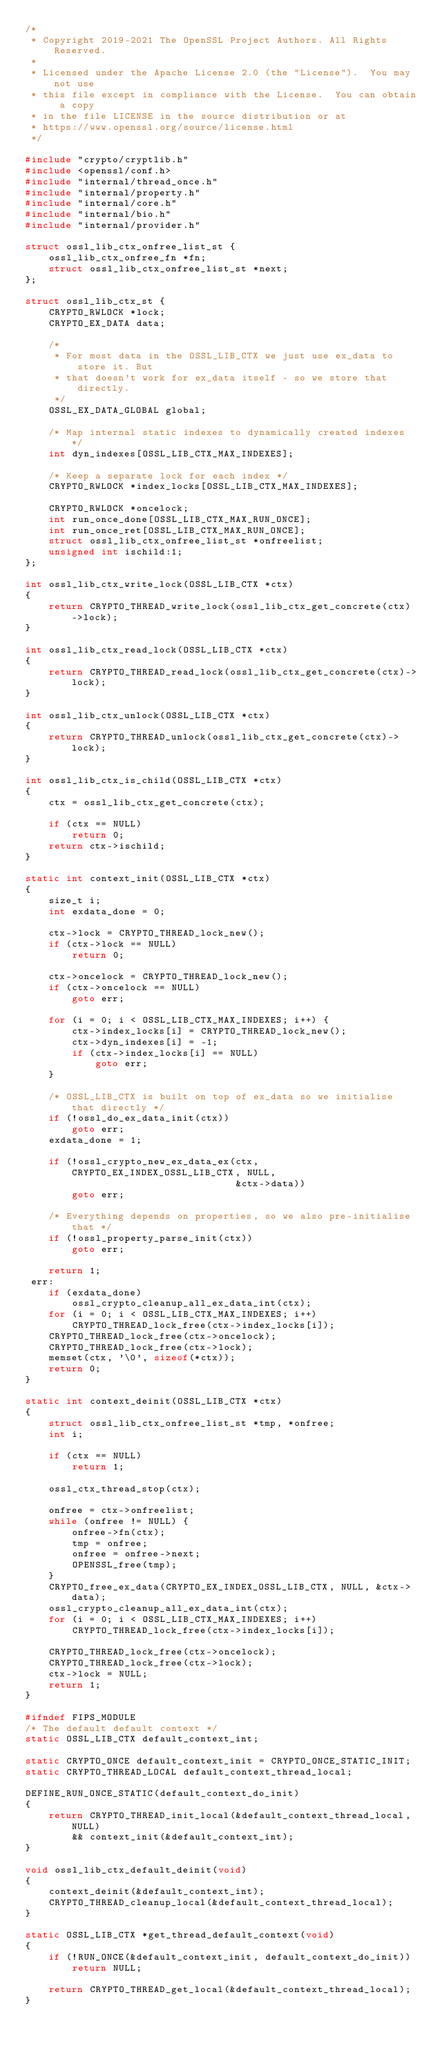Convert code to text. <code><loc_0><loc_0><loc_500><loc_500><_C_>/*
 * Copyright 2019-2021 The OpenSSL Project Authors. All Rights Reserved.
 *
 * Licensed under the Apache License 2.0 (the "License").  You may not use
 * this file except in compliance with the License.  You can obtain a copy
 * in the file LICENSE in the source distribution or at
 * https://www.openssl.org/source/license.html
 */

#include "crypto/cryptlib.h"
#include <openssl/conf.h>
#include "internal/thread_once.h"
#include "internal/property.h"
#include "internal/core.h"
#include "internal/bio.h"
#include "internal/provider.h"

struct ossl_lib_ctx_onfree_list_st {
    ossl_lib_ctx_onfree_fn *fn;
    struct ossl_lib_ctx_onfree_list_st *next;
};

struct ossl_lib_ctx_st {
    CRYPTO_RWLOCK *lock;
    CRYPTO_EX_DATA data;

    /*
     * For most data in the OSSL_LIB_CTX we just use ex_data to store it. But
     * that doesn't work for ex_data itself - so we store that directly.
     */
    OSSL_EX_DATA_GLOBAL global;

    /* Map internal static indexes to dynamically created indexes */
    int dyn_indexes[OSSL_LIB_CTX_MAX_INDEXES];

    /* Keep a separate lock for each index */
    CRYPTO_RWLOCK *index_locks[OSSL_LIB_CTX_MAX_INDEXES];

    CRYPTO_RWLOCK *oncelock;
    int run_once_done[OSSL_LIB_CTX_MAX_RUN_ONCE];
    int run_once_ret[OSSL_LIB_CTX_MAX_RUN_ONCE];
    struct ossl_lib_ctx_onfree_list_st *onfreelist;
    unsigned int ischild:1;
};

int ossl_lib_ctx_write_lock(OSSL_LIB_CTX *ctx)
{
    return CRYPTO_THREAD_write_lock(ossl_lib_ctx_get_concrete(ctx)->lock);
}

int ossl_lib_ctx_read_lock(OSSL_LIB_CTX *ctx)
{
    return CRYPTO_THREAD_read_lock(ossl_lib_ctx_get_concrete(ctx)->lock);
}

int ossl_lib_ctx_unlock(OSSL_LIB_CTX *ctx)
{
    return CRYPTO_THREAD_unlock(ossl_lib_ctx_get_concrete(ctx)->lock);
}

int ossl_lib_ctx_is_child(OSSL_LIB_CTX *ctx)
{
    ctx = ossl_lib_ctx_get_concrete(ctx);

    if (ctx == NULL)
        return 0;
    return ctx->ischild;
}

static int context_init(OSSL_LIB_CTX *ctx)
{
    size_t i;
    int exdata_done = 0;

    ctx->lock = CRYPTO_THREAD_lock_new();
    if (ctx->lock == NULL)
        return 0;

    ctx->oncelock = CRYPTO_THREAD_lock_new();
    if (ctx->oncelock == NULL)
        goto err;

    for (i = 0; i < OSSL_LIB_CTX_MAX_INDEXES; i++) {
        ctx->index_locks[i] = CRYPTO_THREAD_lock_new();
        ctx->dyn_indexes[i] = -1;
        if (ctx->index_locks[i] == NULL)
            goto err;
    }

    /* OSSL_LIB_CTX is built on top of ex_data so we initialise that directly */
    if (!ossl_do_ex_data_init(ctx))
        goto err;
    exdata_done = 1;

    if (!ossl_crypto_new_ex_data_ex(ctx, CRYPTO_EX_INDEX_OSSL_LIB_CTX, NULL,
                                    &ctx->data))
        goto err;

    /* Everything depends on properties, so we also pre-initialise that */
    if (!ossl_property_parse_init(ctx))
        goto err;

    return 1;
 err:
    if (exdata_done)
        ossl_crypto_cleanup_all_ex_data_int(ctx);
    for (i = 0; i < OSSL_LIB_CTX_MAX_INDEXES; i++)
        CRYPTO_THREAD_lock_free(ctx->index_locks[i]);
    CRYPTO_THREAD_lock_free(ctx->oncelock);
    CRYPTO_THREAD_lock_free(ctx->lock);
    memset(ctx, '\0', sizeof(*ctx));
    return 0;
}

static int context_deinit(OSSL_LIB_CTX *ctx)
{
    struct ossl_lib_ctx_onfree_list_st *tmp, *onfree;
    int i;

    if (ctx == NULL)
        return 1;

    ossl_ctx_thread_stop(ctx);

    onfree = ctx->onfreelist;
    while (onfree != NULL) {
        onfree->fn(ctx);
        tmp = onfree;
        onfree = onfree->next;
        OPENSSL_free(tmp);
    }
    CRYPTO_free_ex_data(CRYPTO_EX_INDEX_OSSL_LIB_CTX, NULL, &ctx->data);
    ossl_crypto_cleanup_all_ex_data_int(ctx);
    for (i = 0; i < OSSL_LIB_CTX_MAX_INDEXES; i++)
        CRYPTO_THREAD_lock_free(ctx->index_locks[i]);

    CRYPTO_THREAD_lock_free(ctx->oncelock);
    CRYPTO_THREAD_lock_free(ctx->lock);
    ctx->lock = NULL;
    return 1;
}

#ifndef FIPS_MODULE
/* The default default context */
static OSSL_LIB_CTX default_context_int;

static CRYPTO_ONCE default_context_init = CRYPTO_ONCE_STATIC_INIT;
static CRYPTO_THREAD_LOCAL default_context_thread_local;

DEFINE_RUN_ONCE_STATIC(default_context_do_init)
{
    return CRYPTO_THREAD_init_local(&default_context_thread_local, NULL)
        && context_init(&default_context_int);
}

void ossl_lib_ctx_default_deinit(void)
{
    context_deinit(&default_context_int);
    CRYPTO_THREAD_cleanup_local(&default_context_thread_local);
}

static OSSL_LIB_CTX *get_thread_default_context(void)
{
    if (!RUN_ONCE(&default_context_init, default_context_do_init))
        return NULL;

    return CRYPTO_THREAD_get_local(&default_context_thread_local);
}
</code> 